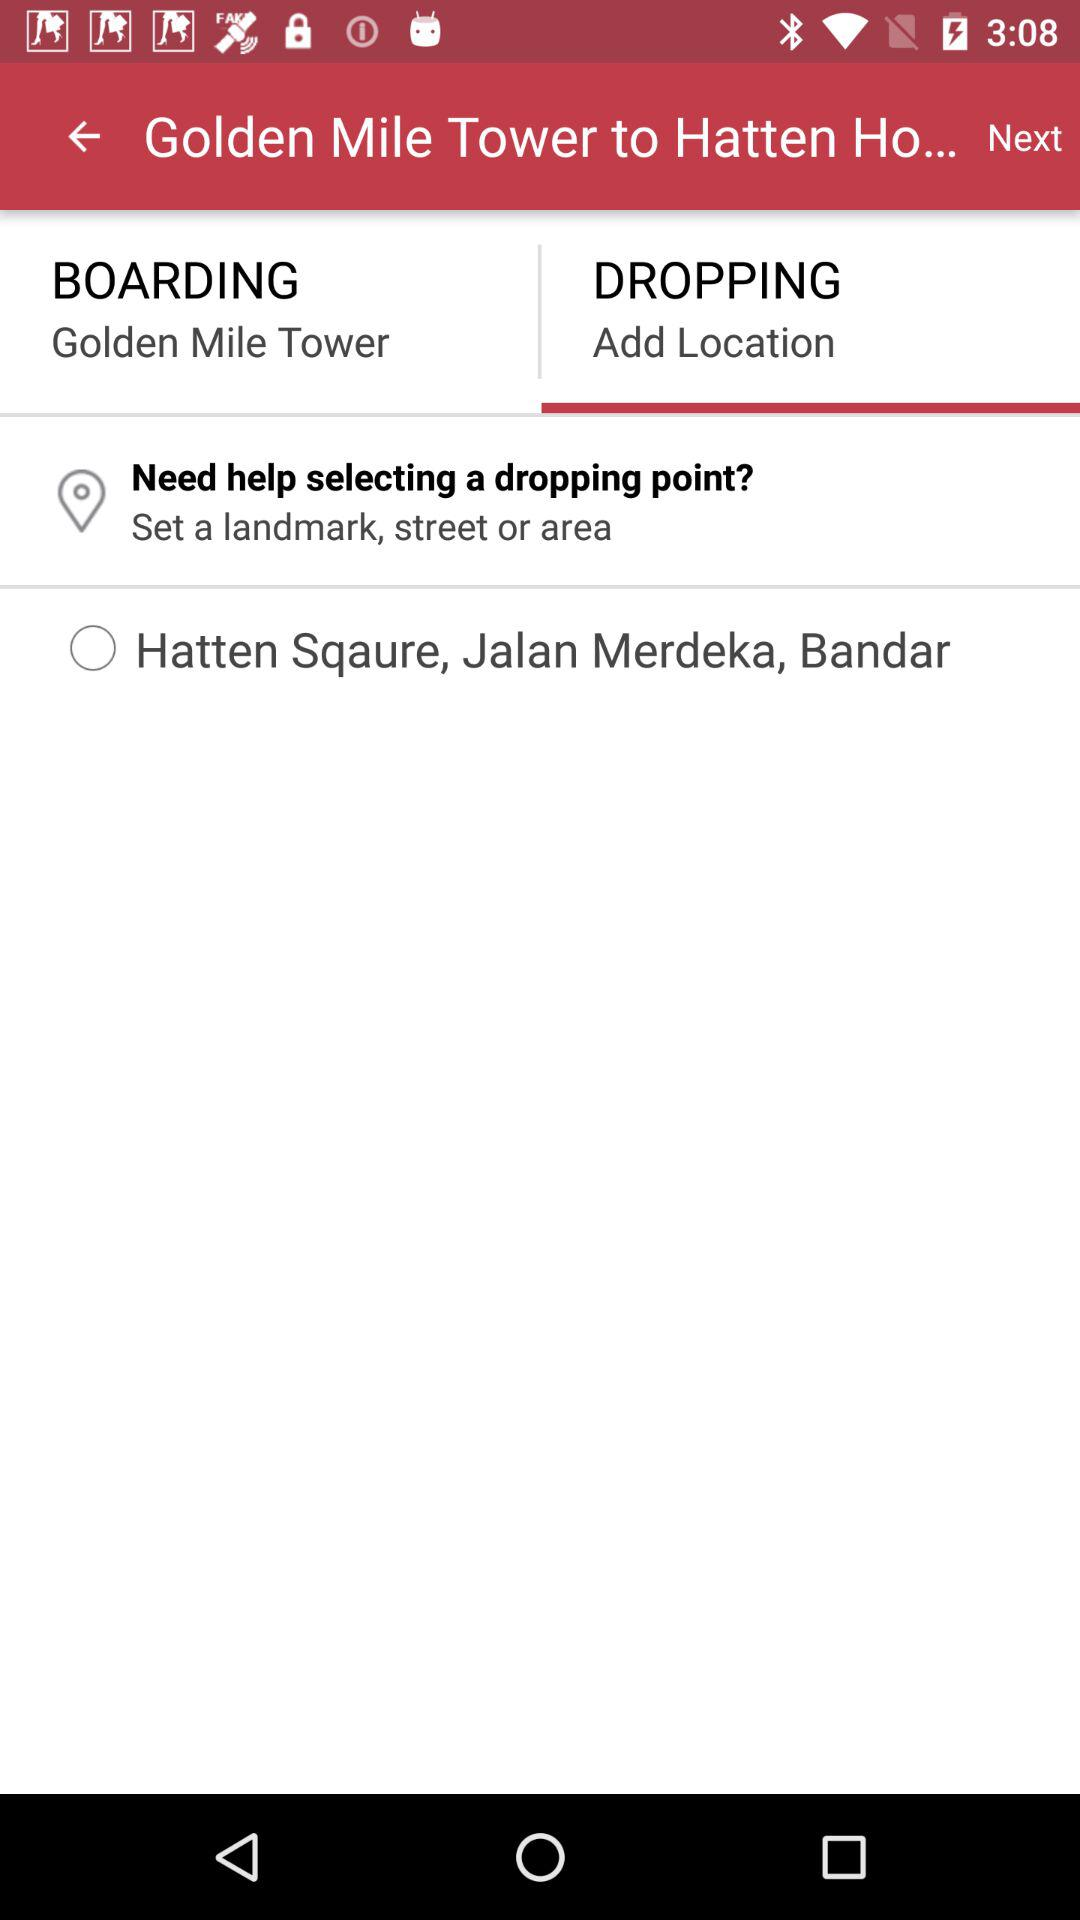What is the selected boarding location? The selected boarding location is "Golden Mile Tower". 